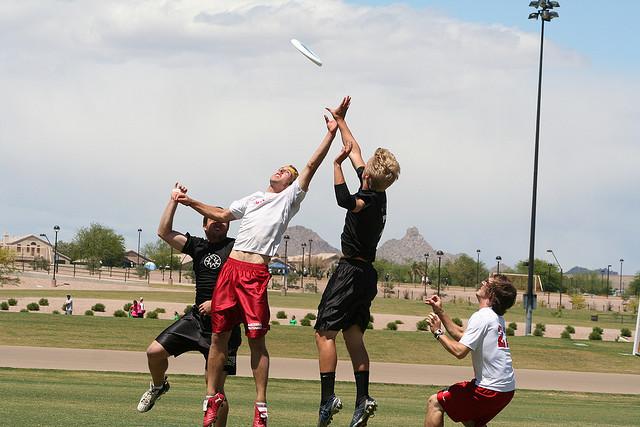Is this indoors?
Write a very short answer. No. What is the color of the grass?
Be succinct. Green. What are these people playing with?
Write a very short answer. Frisbee. 